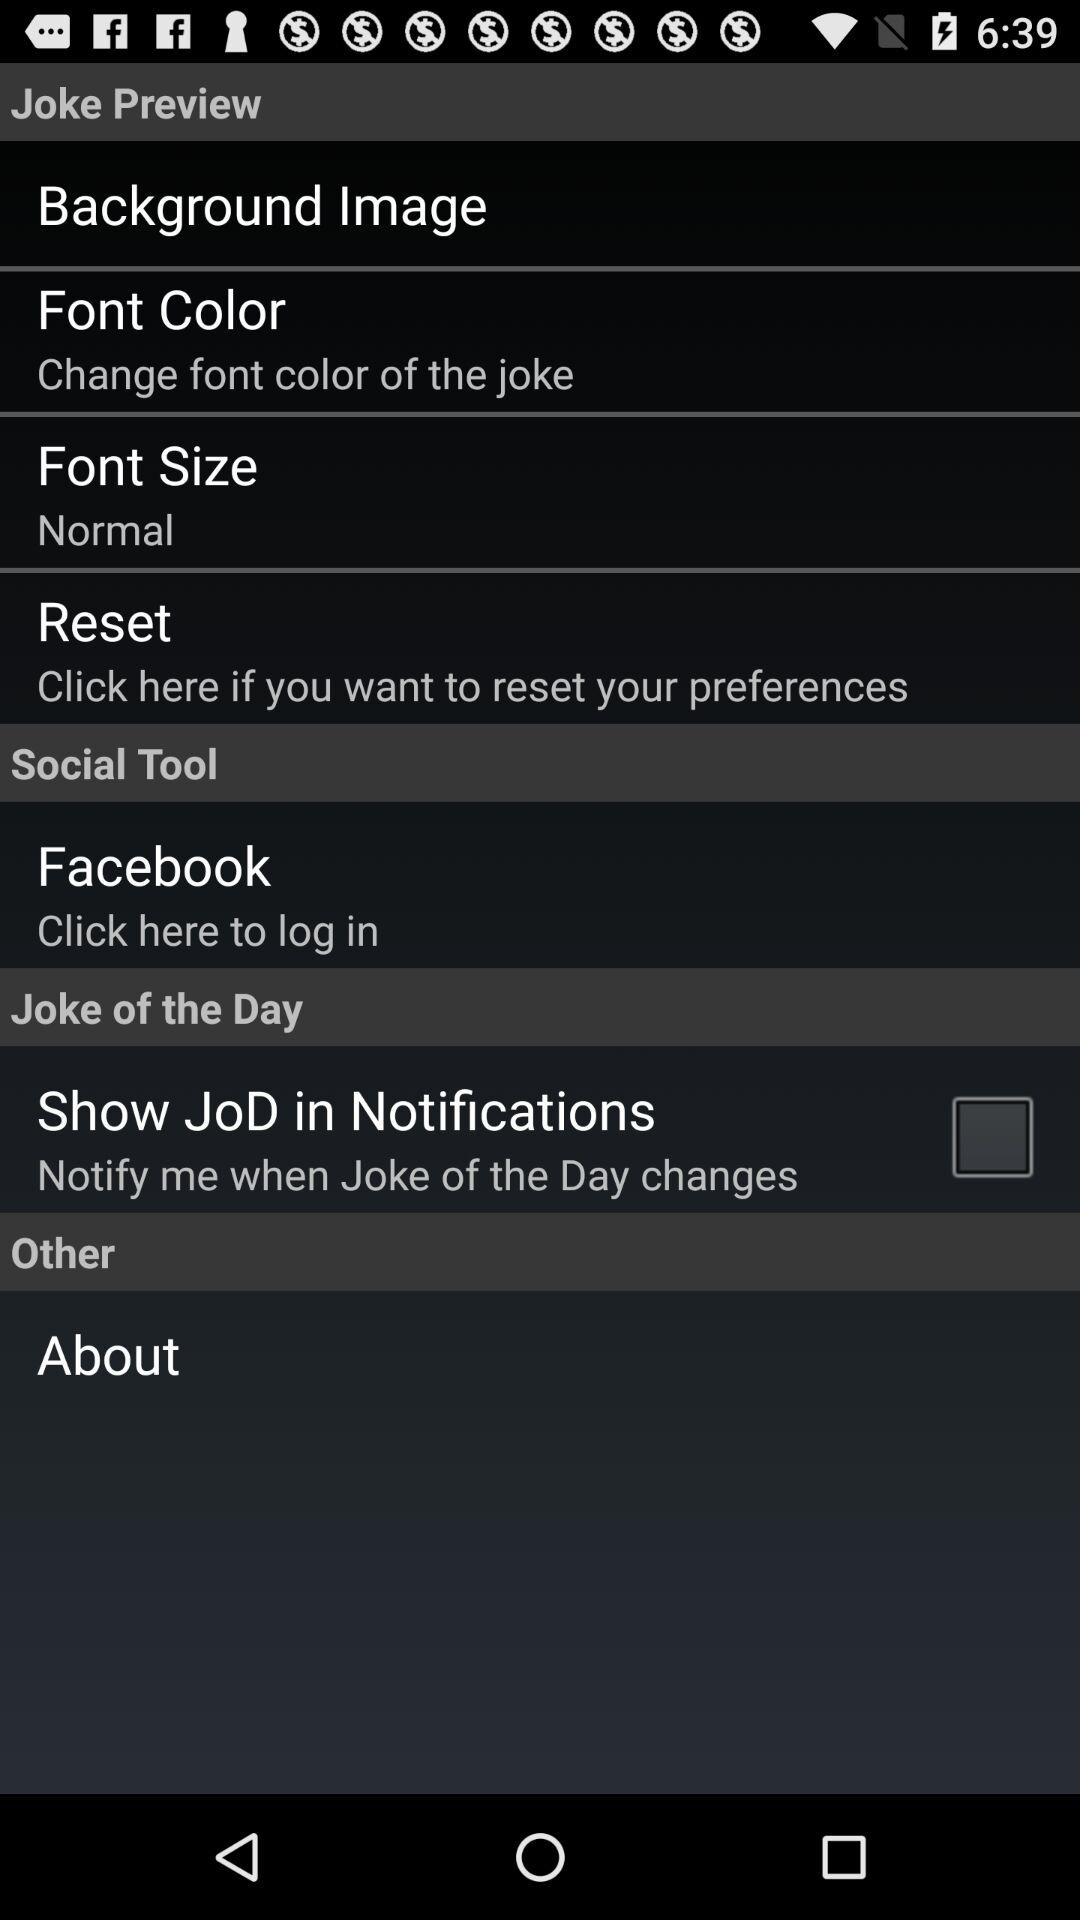How many items have a checkbox in the 'Joke of the Day' section?
Answer the question using a single word or phrase. 1 